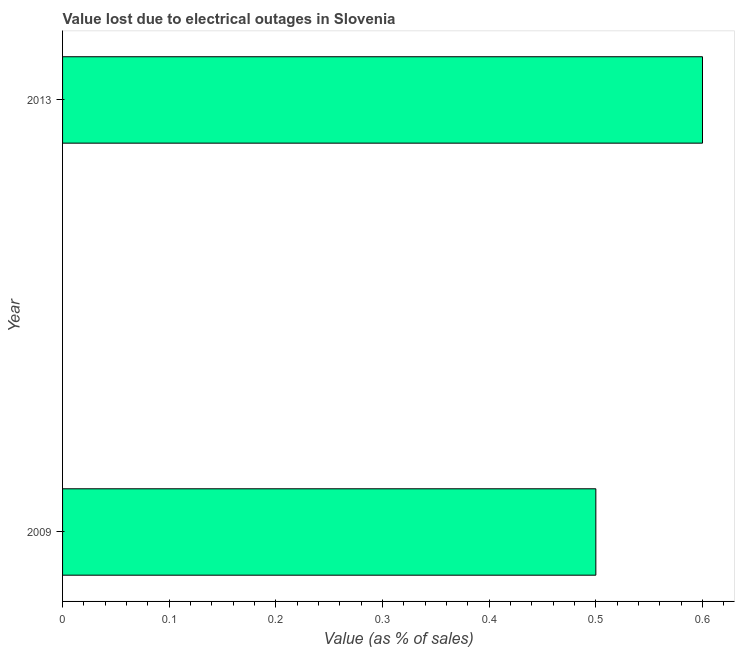Does the graph contain any zero values?
Keep it short and to the point. No. Does the graph contain grids?
Your response must be concise. No. What is the title of the graph?
Make the answer very short. Value lost due to electrical outages in Slovenia. What is the label or title of the X-axis?
Keep it short and to the point. Value (as % of sales). What is the label or title of the Y-axis?
Your answer should be compact. Year. What is the value lost due to electrical outages in 2009?
Keep it short and to the point. 0.5. Across all years, what is the maximum value lost due to electrical outages?
Ensure brevity in your answer.  0.6. In which year was the value lost due to electrical outages maximum?
Your answer should be very brief. 2013. What is the average value lost due to electrical outages per year?
Your response must be concise. 0.55. What is the median value lost due to electrical outages?
Keep it short and to the point. 0.55. What is the ratio of the value lost due to electrical outages in 2009 to that in 2013?
Make the answer very short. 0.83. Is the value lost due to electrical outages in 2009 less than that in 2013?
Give a very brief answer. Yes. In how many years, is the value lost due to electrical outages greater than the average value lost due to electrical outages taken over all years?
Your answer should be compact. 1. How many bars are there?
Keep it short and to the point. 2. What is the difference between two consecutive major ticks on the X-axis?
Keep it short and to the point. 0.1. What is the Value (as % of sales) in 2009?
Keep it short and to the point. 0.5. What is the Value (as % of sales) of 2013?
Ensure brevity in your answer.  0.6. What is the difference between the Value (as % of sales) in 2009 and 2013?
Offer a terse response. -0.1. What is the ratio of the Value (as % of sales) in 2009 to that in 2013?
Provide a succinct answer. 0.83. 